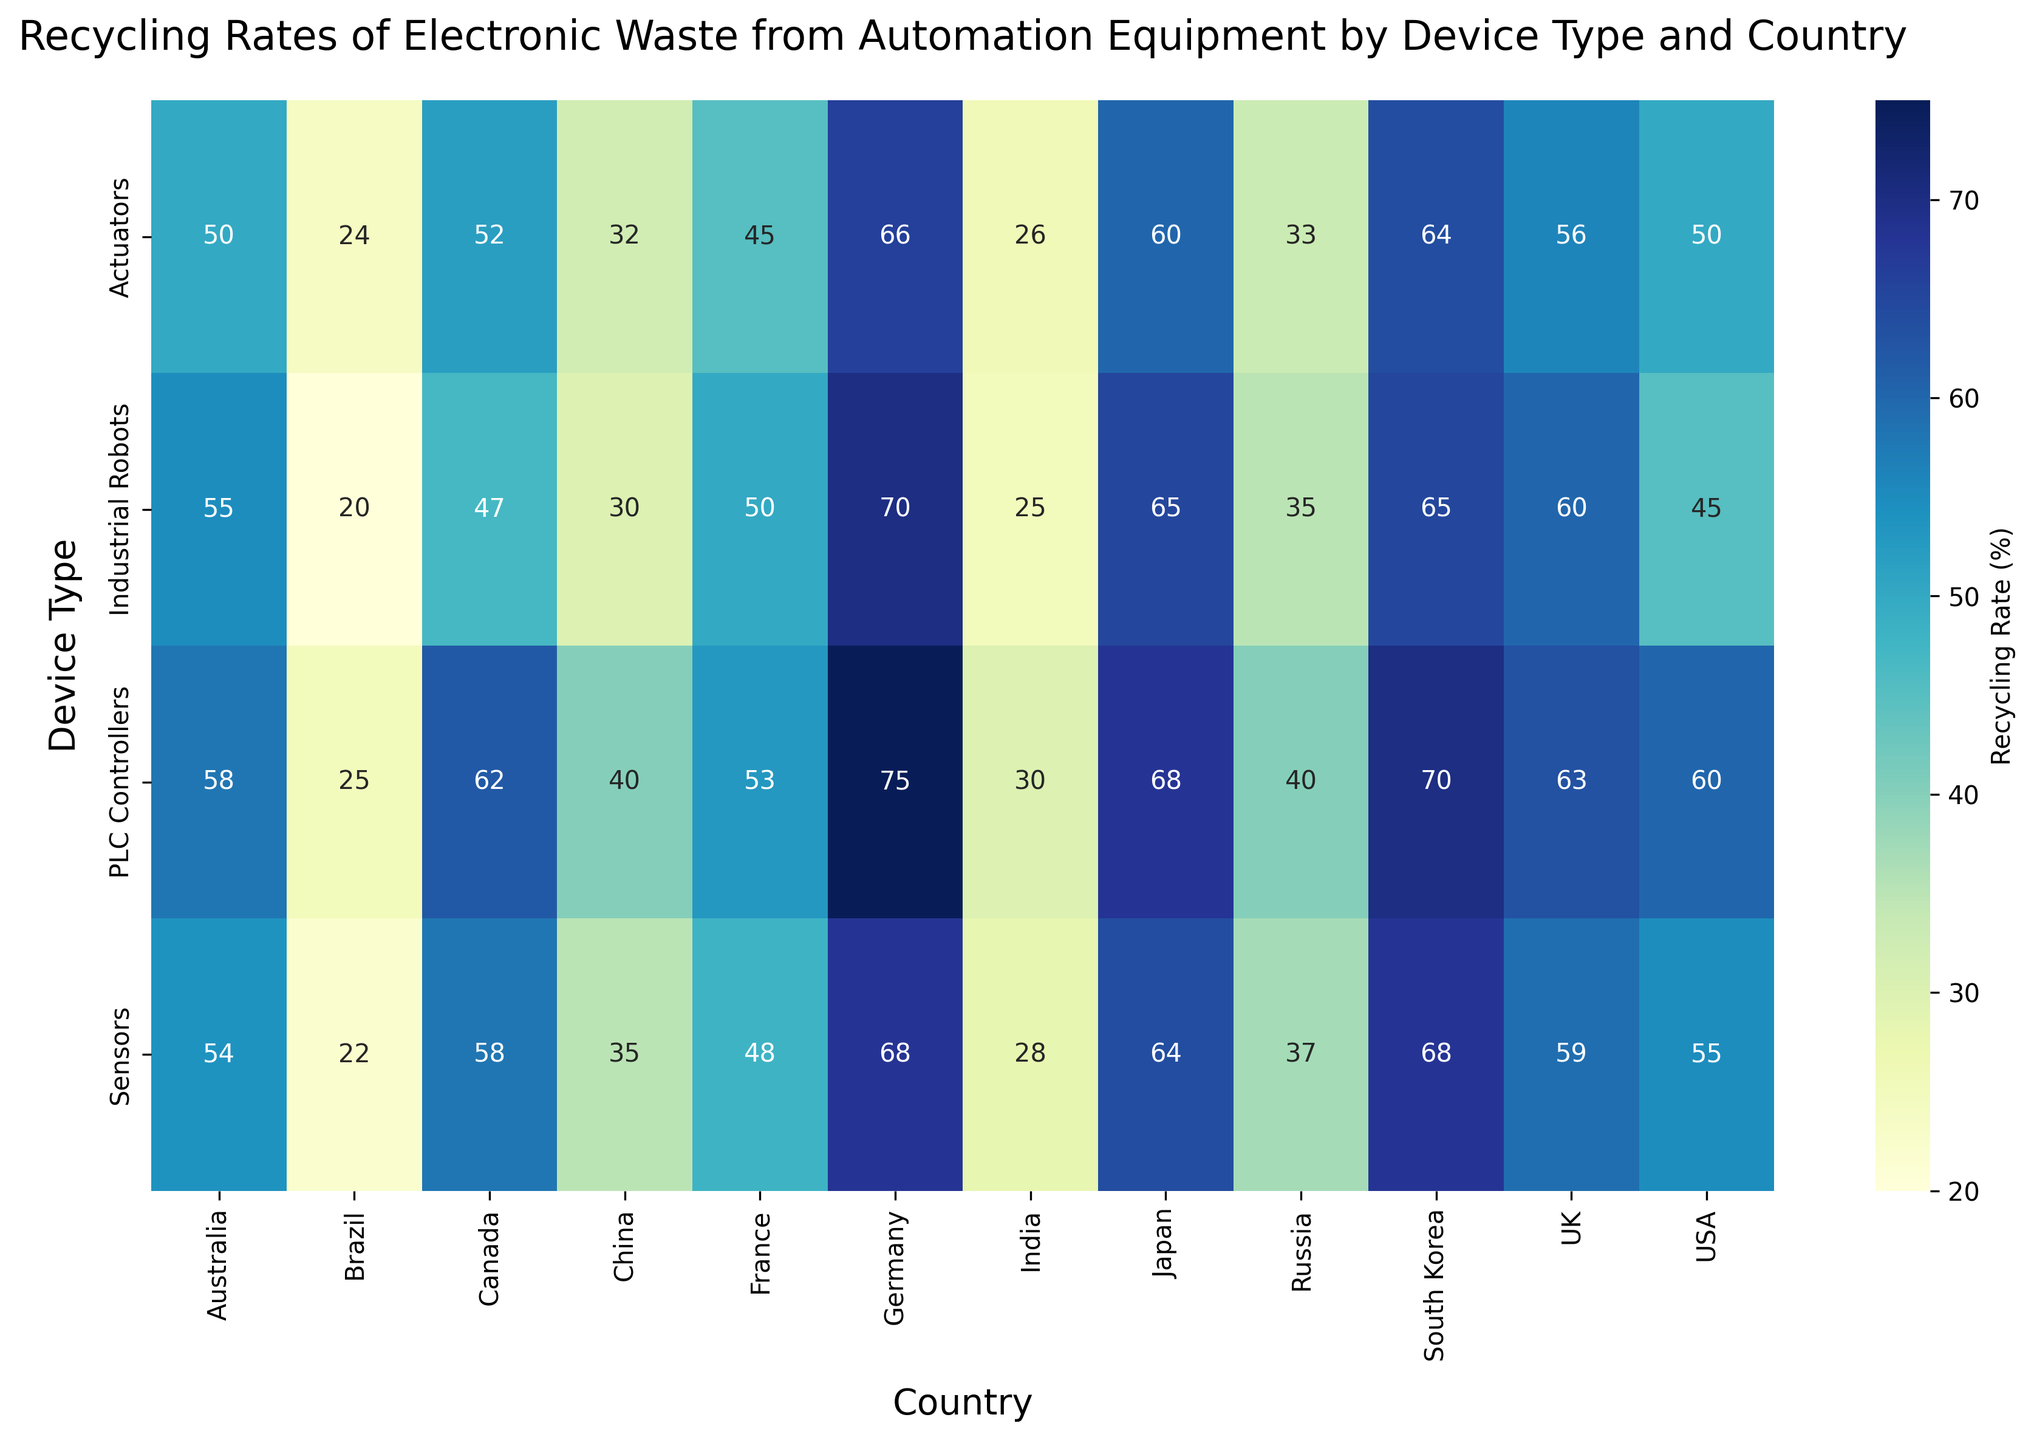What country has the highest recycling rate for Industrial Robots? To determine the country with the highest recycling rate for Industrial Robots, look at the row labeled 'Industrial Robots' and find the largest value. Germany has a recycling rate of 70%, which is the highest for Industrial Robots.
Answer: Germany Which device type in the USA has the highest recycling rate? To identify the device type with the highest recycling rate in the USA, locate the column for the USA and find the row with the highest value. PLC Controllers have a recycling rate of 60%, which is the highest in the USA.
Answer: PLC Controllers What is the average recycling rate for Sensors across all countries? To find the average recycling rate for Sensors, sum the recycling rates found in the 'Sensors' row and divide by the number of countries. The sum is 55+58+68+35+28+64+22+54+59+48+68+37 = 596, and there are 12 countries, thus average is 596/12 = 49.67.
Answer: 49.67 Compare the recycling rates for Japan and South Korea across all device types. Which country has a higher overall average recycling rate? Calculate the average recycling rates for all device types in Japan and South Korea respectively. For Japan: (65+68+64+60)/4 = 64.25. For South Korea: (65+70+68+64)/4 = 66.75. South Korea has a higher overall average.
Answer: South Korea What is the largest difference in recycling rates for any single device type between two countries? To find the largest difference, examine the difference in recycling rates for each device type between the highest and lowest values across countries. For example, the difference for Industrial Robots is between Germany (70%) and Brazil (20%), resulting in 70-20=50, which is the largest among all device types.
Answer: 50 In which country is there the smallest range in recycling rates across all device types? Find the range between the highest and lowest recycling rates for each country, and identify the smallest range. For USA: 60-45=15, Canada: 62-47=15, Germany: 75-66=9, China: 40-30=10, India: 30-25=5, Japan: 68-60=8, Brazil: 25-20=5, Australia: 58-50=8, UK: 63-56=7, France: 53-45=8, South Korea: 70-64=6, Russia: 40-33=7. The smallest range is found in India and Brazil, both with a range of 5.
Answer: India and Brazil Which device type shows the greatest variability in recycling rates across countries? Calculate the range for each device type. Industrial Robots: 70-20=50, PLC Controllers: 75-25=50, Sensors: 68-22=46, Actuators: 66-24=42. The Industrial Robots and PLC Controllers both show the highest variability with a range of 50.
Answer: Industrial Robots and PLC Controllers What is the difference between the highest recycling rates of PLC Controllers and Sensors? Identify the highest recycling rates for PLC Controllers and Sensors, which are 75% (Germany) and 68% (Germany and South Korea) respectively, then compute the difference. 75-68=7.
Answer: 7 Which device type has the lowest recycling rate in India, and what is the value? Look at the 'India' column and find the row with the lowest value. Actuators have the lowest recycling rate in India at 26%.
Answer: Actuators, 26 If Brazil increases its recycling rate by 10% for all device types, what would be the new recycling rate for Industrial Robots? Calculate the new recycling rate for Industrial Robots in Brazil by adding 10% to the current rate, which is 20%. Thus, 20+10 = 30.
Answer: 30 